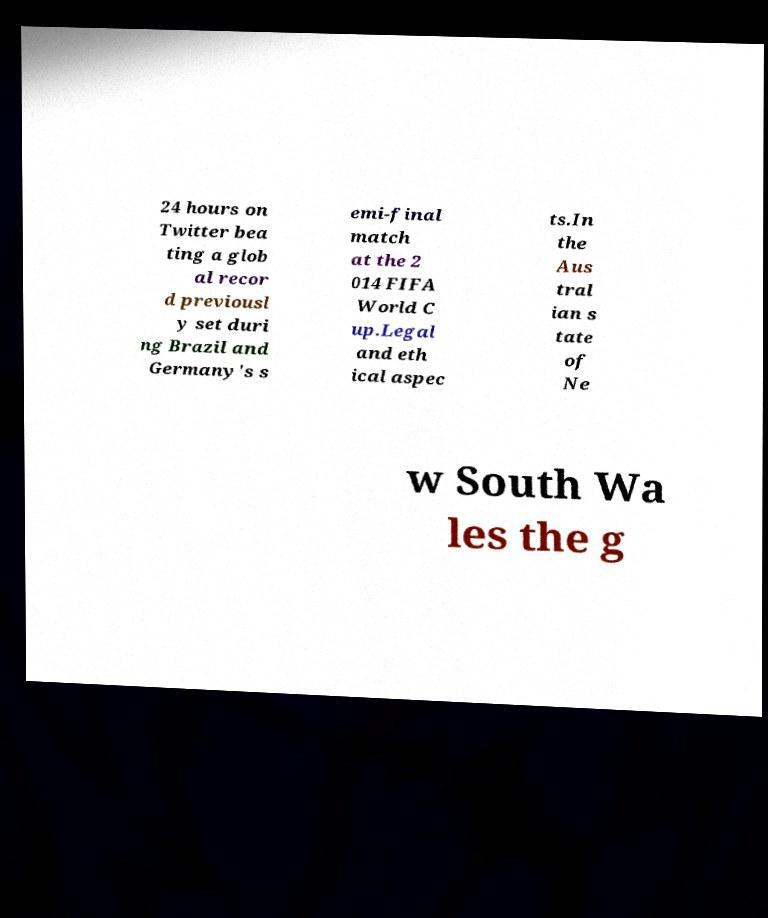There's text embedded in this image that I need extracted. Can you transcribe it verbatim? 24 hours on Twitter bea ting a glob al recor d previousl y set duri ng Brazil and Germany's s emi-final match at the 2 014 FIFA World C up.Legal and eth ical aspec ts.In the Aus tral ian s tate of Ne w South Wa les the g 